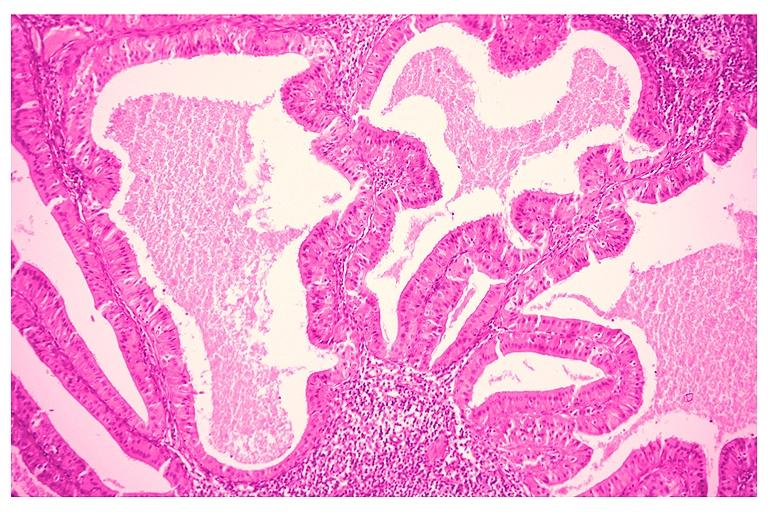what does this image show?
Answer the question using a single word or phrase. Papillary cystadenoma lymphomatosum warthins 